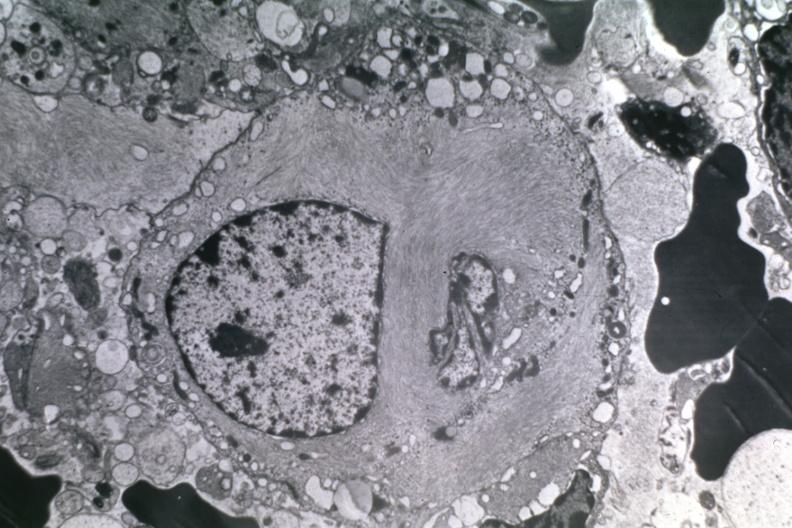does inflamed exocervix show dr garcia tumors 10?
Answer the question using a single word or phrase. No 